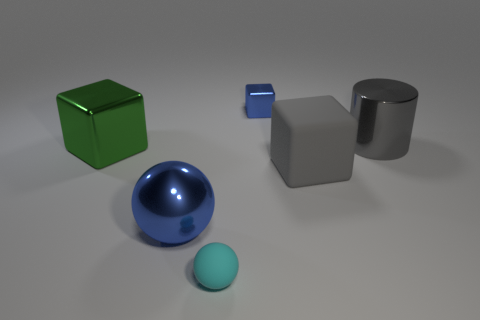Is the color of the big sphere the same as the cube that is behind the shiny cylinder?
Offer a very short reply. Yes. What is the shape of the rubber object that is the same color as the large cylinder?
Offer a terse response. Cube. What material is the big cube on the right side of the blue metal thing on the left side of the tiny thing in front of the blue block?
Give a very brief answer. Rubber. Do the metal thing that is right of the blue metallic block and the large green object have the same shape?
Make the answer very short. No. What is the thing that is on the left side of the blue metal ball made of?
Provide a succinct answer. Metal. What number of rubber things are either big gray objects or tiny things?
Provide a succinct answer. 2. Is there a blue rubber cylinder of the same size as the gray rubber cube?
Offer a very short reply. No. Is the number of large cylinders on the left side of the big green metal block greater than the number of tiny yellow shiny things?
Provide a succinct answer. No. How many large things are either cubes or blue metal objects?
Keep it short and to the point. 3. What number of other large shiny things are the same shape as the large green metallic thing?
Provide a succinct answer. 0. 